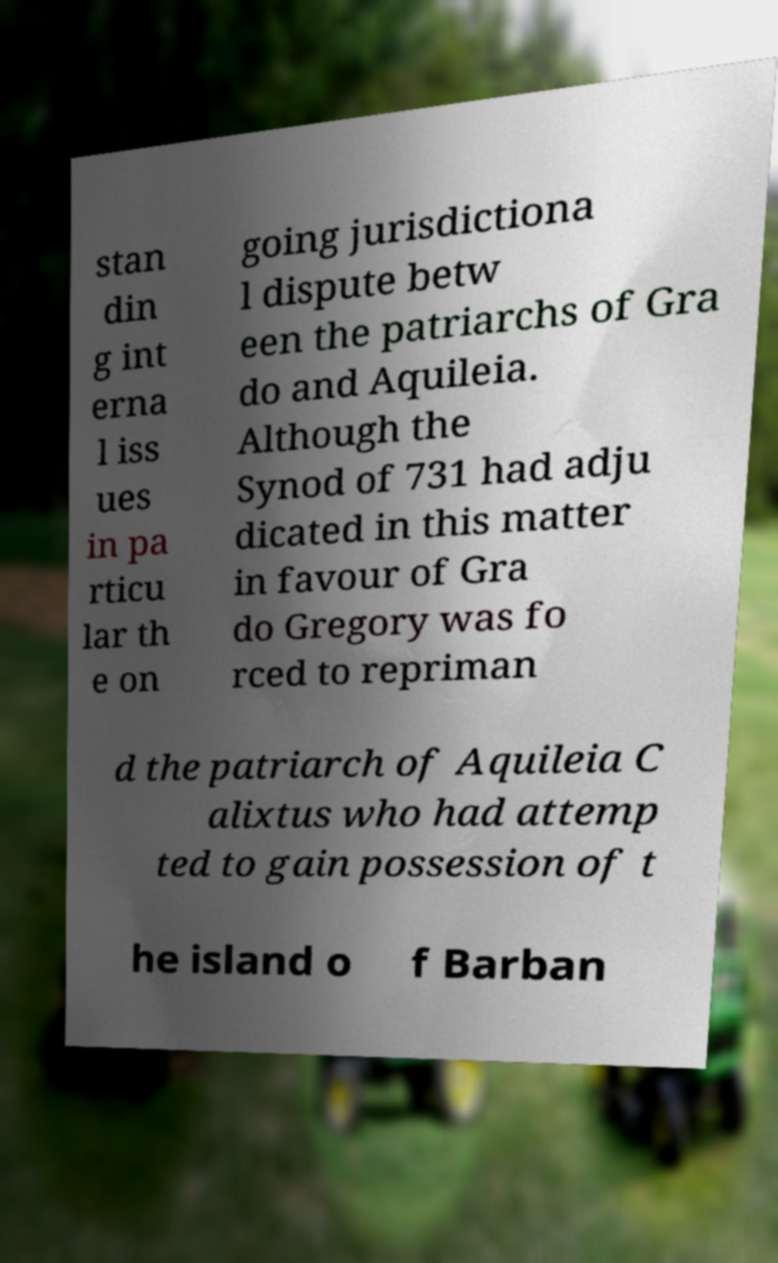What messages or text are displayed in this image? I need them in a readable, typed format. stan din g int erna l iss ues in pa rticu lar th e on going jurisdictiona l dispute betw een the patriarchs of Gra do and Aquileia. Although the Synod of 731 had adju dicated in this matter in favour of Gra do Gregory was fo rced to repriman d the patriarch of Aquileia C alixtus who had attemp ted to gain possession of t he island o f Barban 